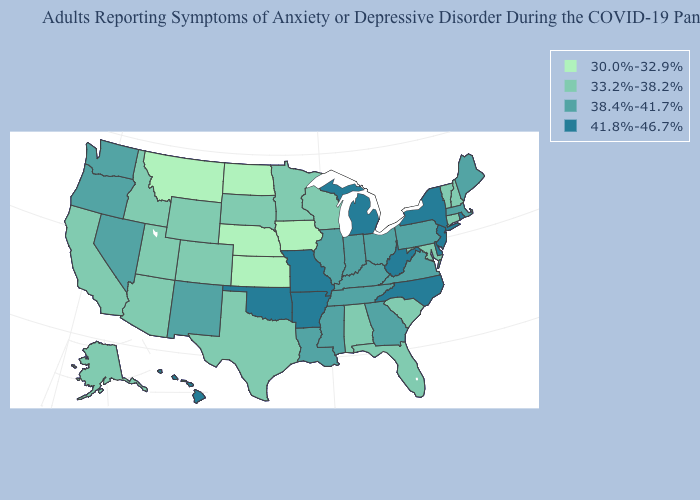Which states have the highest value in the USA?
Be succinct. Arkansas, Delaware, Hawaii, Michigan, Missouri, New Jersey, New York, North Carolina, Oklahoma, Rhode Island, West Virginia. What is the value of Nebraska?
Give a very brief answer. 30.0%-32.9%. What is the value of Louisiana?
Keep it brief. 38.4%-41.7%. Name the states that have a value in the range 33.2%-38.2%?
Be succinct. Alabama, Alaska, Arizona, California, Colorado, Connecticut, Florida, Idaho, Maryland, Minnesota, New Hampshire, South Carolina, South Dakota, Texas, Utah, Vermont, Wisconsin, Wyoming. Does the map have missing data?
Be succinct. No. Name the states that have a value in the range 33.2%-38.2%?
Write a very short answer. Alabama, Alaska, Arizona, California, Colorado, Connecticut, Florida, Idaho, Maryland, Minnesota, New Hampshire, South Carolina, South Dakota, Texas, Utah, Vermont, Wisconsin, Wyoming. Name the states that have a value in the range 33.2%-38.2%?
Write a very short answer. Alabama, Alaska, Arizona, California, Colorado, Connecticut, Florida, Idaho, Maryland, Minnesota, New Hampshire, South Carolina, South Dakota, Texas, Utah, Vermont, Wisconsin, Wyoming. Does Georgia have the highest value in the USA?
Answer briefly. No. Does New York have the lowest value in the Northeast?
Short answer required. No. What is the value of Arizona?
Give a very brief answer. 33.2%-38.2%. Does Kansas have the lowest value in the USA?
Quick response, please. Yes. Which states hav the highest value in the South?
Keep it brief. Arkansas, Delaware, North Carolina, Oklahoma, West Virginia. Among the states that border Oregon , which have the highest value?
Answer briefly. Nevada, Washington. Among the states that border Mississippi , does Louisiana have the lowest value?
Write a very short answer. No. Name the states that have a value in the range 33.2%-38.2%?
Concise answer only. Alabama, Alaska, Arizona, California, Colorado, Connecticut, Florida, Idaho, Maryland, Minnesota, New Hampshire, South Carolina, South Dakota, Texas, Utah, Vermont, Wisconsin, Wyoming. 